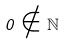Convert formula to latex. <formula><loc_0><loc_0><loc_500><loc_500>0 \notin \mathbb { N }</formula> 